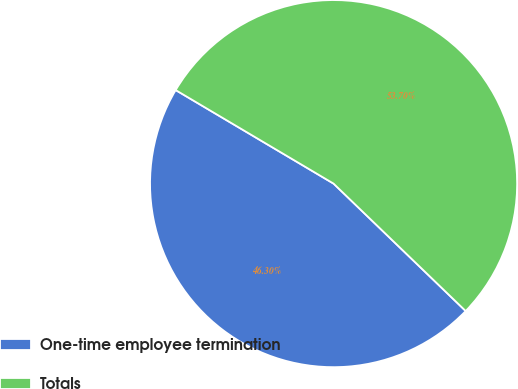<chart> <loc_0><loc_0><loc_500><loc_500><pie_chart><fcel>One-time employee termination<fcel>Totals<nl><fcel>46.3%<fcel>53.7%<nl></chart> 